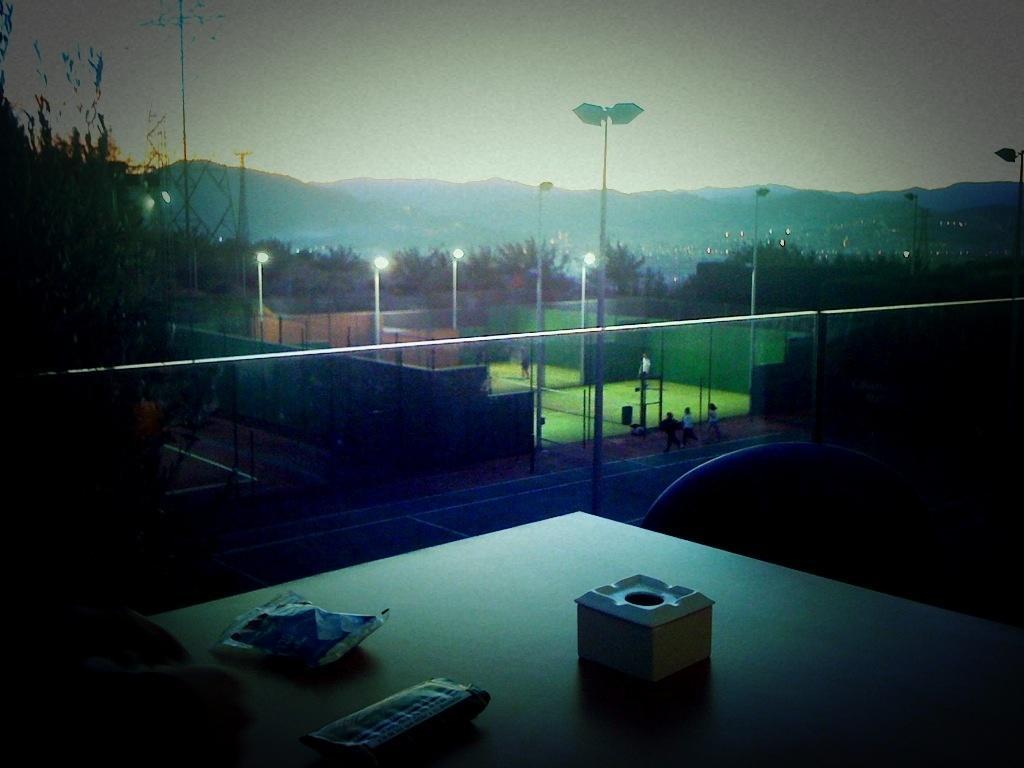Please provide a concise description of this image. In this image is dark on the left and right corner. There is a table with objects on it in the foreground. There is a glass railing. And is a playground and poles with lights, there are trees and mountains in the background. And there is sky at the top. 